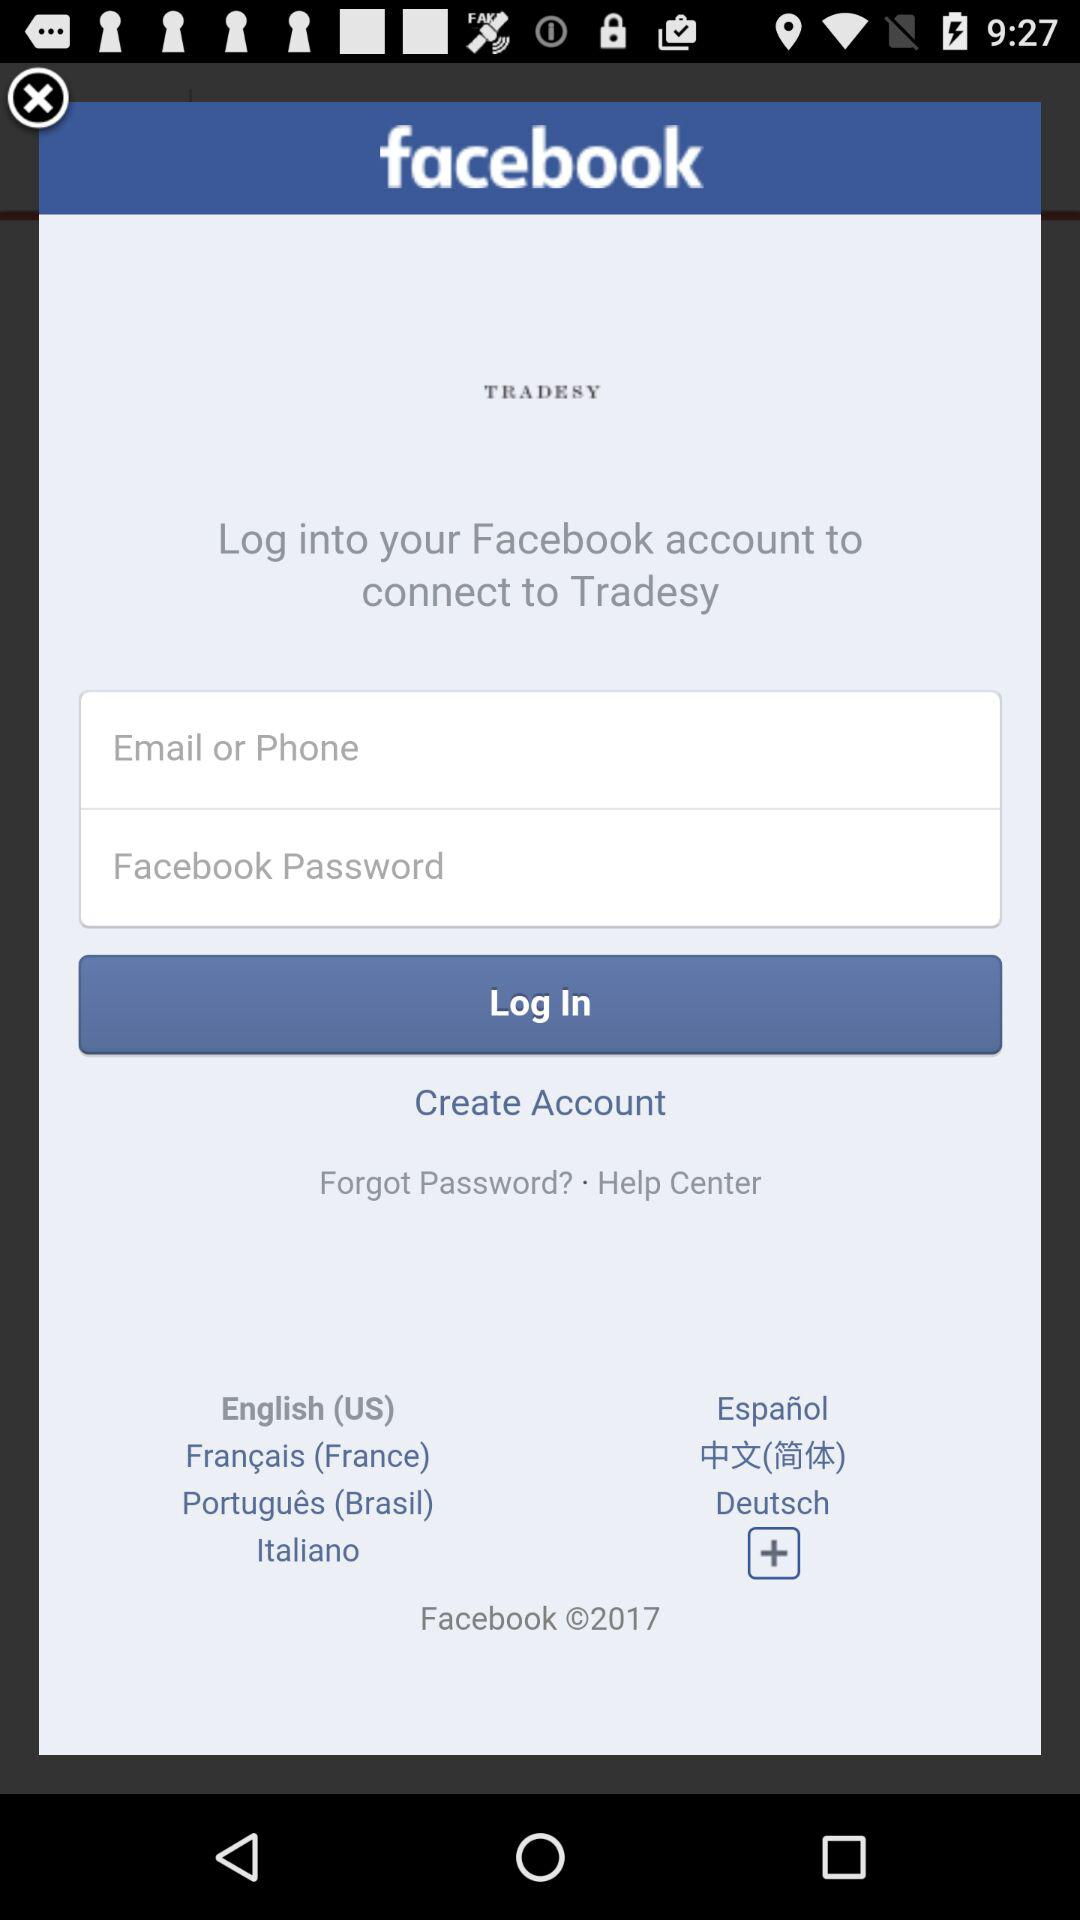Through what application can we log in? You can log in through "Facebook". 